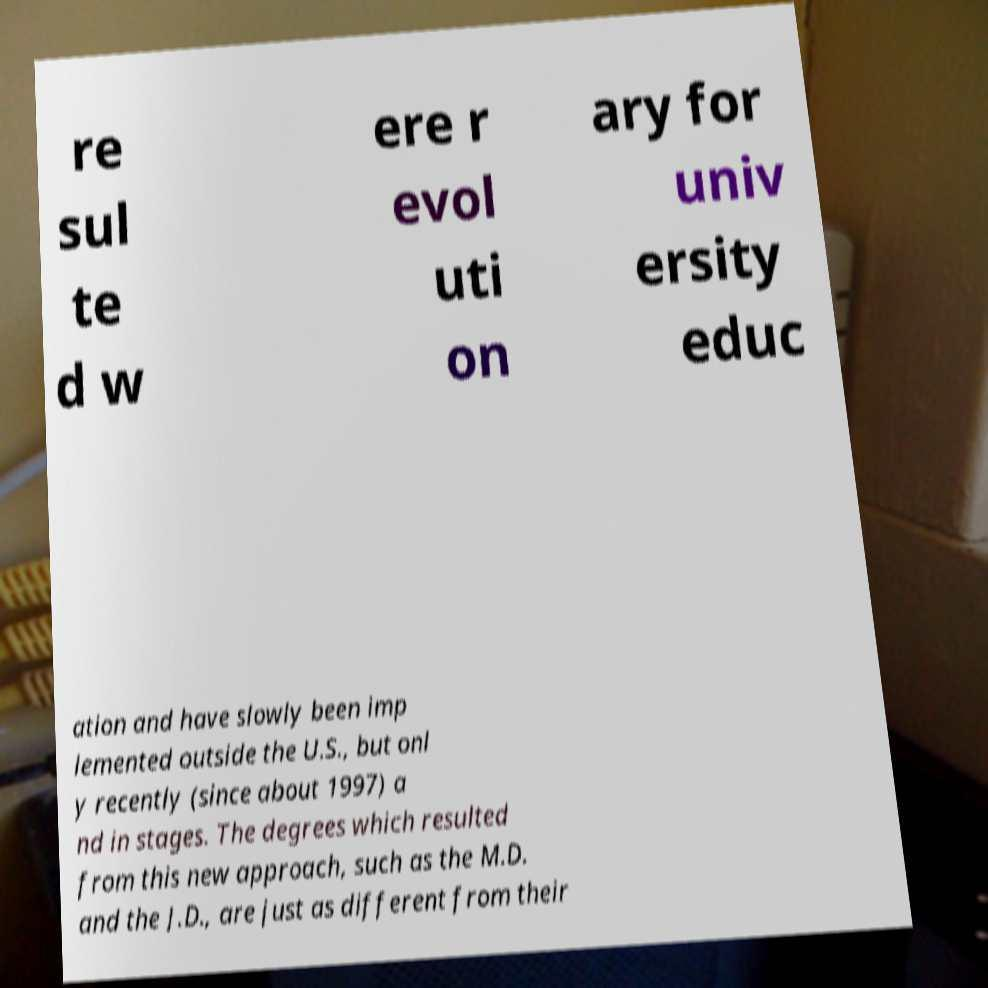There's text embedded in this image that I need extracted. Can you transcribe it verbatim? re sul te d w ere r evol uti on ary for univ ersity educ ation and have slowly been imp lemented outside the U.S., but onl y recently (since about 1997) a nd in stages. The degrees which resulted from this new approach, such as the M.D. and the J.D., are just as different from their 